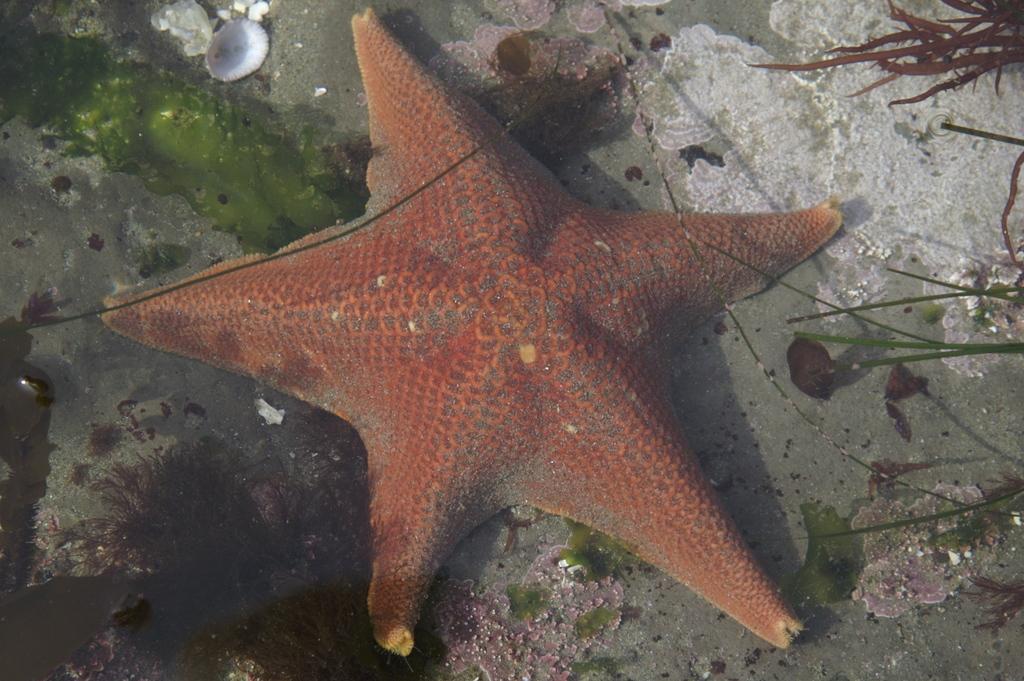Could you give a brief overview of what you see in this image? In the picture there is a star fish and around the star fish there is a shell, some grass leaves and other items. 